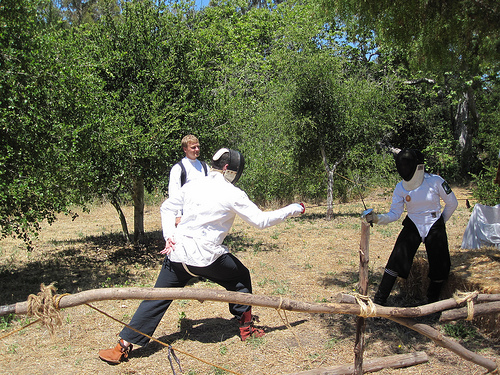<image>
Can you confirm if the person is next to the person? Yes. The person is positioned adjacent to the person, located nearby in the same general area. 